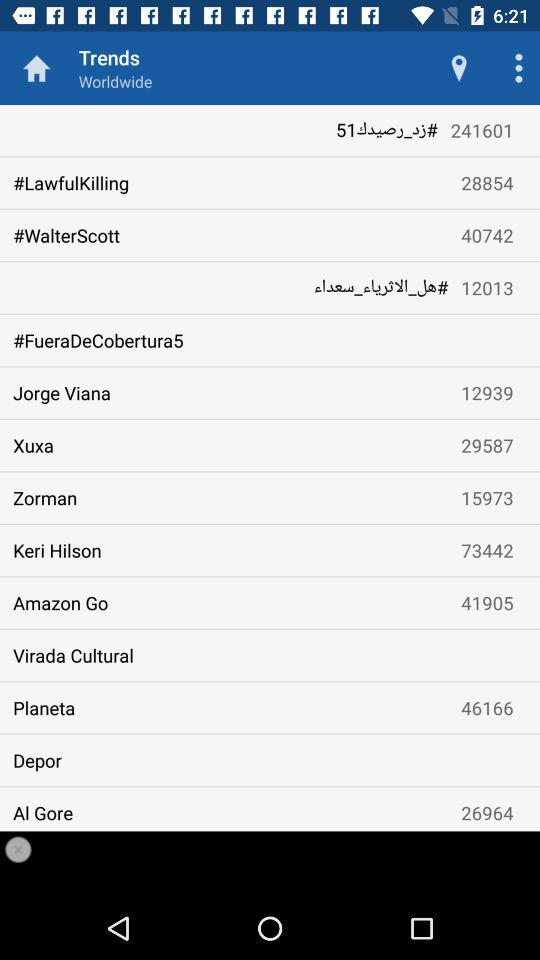How many hashtags are associated with "Planeta"? There are 46166 hashtags associated with "Planeta". 